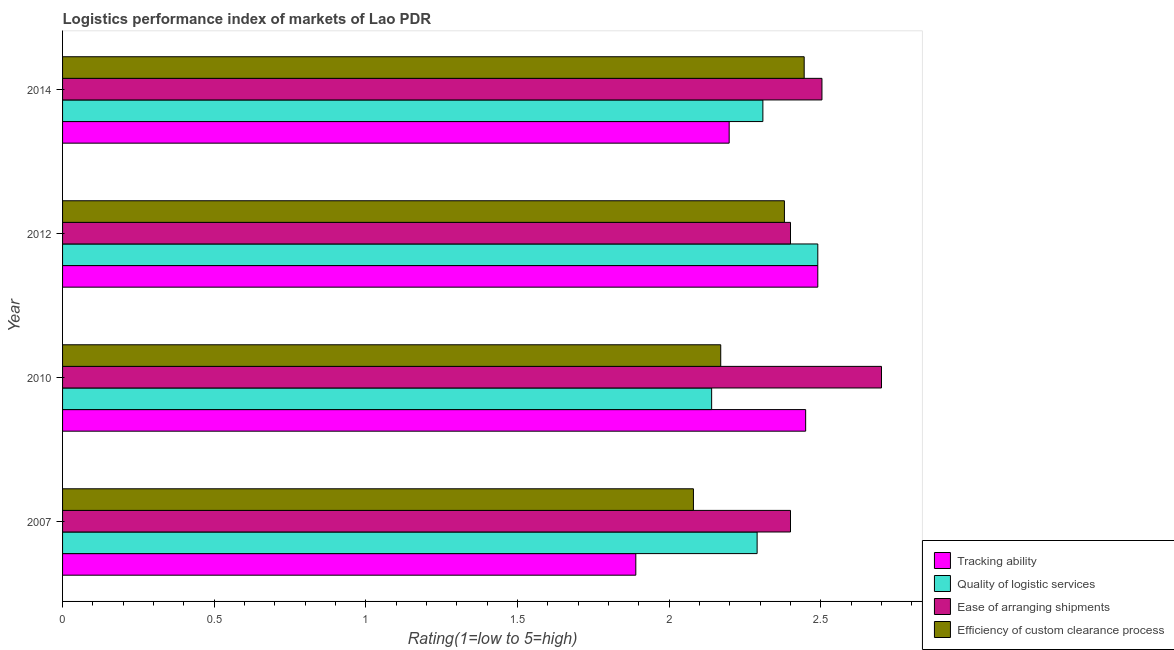Are the number of bars per tick equal to the number of legend labels?
Your answer should be compact. Yes. Are the number of bars on each tick of the Y-axis equal?
Your answer should be compact. Yes. How many bars are there on the 4th tick from the top?
Your response must be concise. 4. How many bars are there on the 1st tick from the bottom?
Keep it short and to the point. 4. What is the lpi rating of quality of logistic services in 2014?
Make the answer very short. 2.31. Across all years, what is the maximum lpi rating of tracking ability?
Your answer should be compact. 2.49. Across all years, what is the minimum lpi rating of ease of arranging shipments?
Offer a very short reply. 2.4. In which year was the lpi rating of tracking ability minimum?
Provide a short and direct response. 2007. What is the total lpi rating of efficiency of custom clearance process in the graph?
Offer a terse response. 9.08. What is the difference between the lpi rating of efficiency of custom clearance process in 2012 and that in 2014?
Your answer should be very brief. -0.07. What is the difference between the lpi rating of tracking ability in 2012 and the lpi rating of quality of logistic services in 2014?
Your answer should be compact. 0.18. What is the average lpi rating of tracking ability per year?
Make the answer very short. 2.26. In the year 2010, what is the difference between the lpi rating of quality of logistic services and lpi rating of tracking ability?
Make the answer very short. -0.31. In how many years, is the lpi rating of tracking ability greater than 1.3 ?
Offer a very short reply. 4. What is the ratio of the lpi rating of quality of logistic services in 2007 to that in 2014?
Offer a very short reply. 0.99. Is the lpi rating of ease of arranging shipments in 2007 less than that in 2014?
Give a very brief answer. Yes. What is the difference between the highest and the second highest lpi rating of tracking ability?
Make the answer very short. 0.04. Is it the case that in every year, the sum of the lpi rating of quality of logistic services and lpi rating of tracking ability is greater than the sum of lpi rating of ease of arranging shipments and lpi rating of efficiency of custom clearance process?
Make the answer very short. No. What does the 1st bar from the top in 2014 represents?
Ensure brevity in your answer.  Efficiency of custom clearance process. What does the 1st bar from the bottom in 2010 represents?
Offer a very short reply. Tracking ability. Is it the case that in every year, the sum of the lpi rating of tracking ability and lpi rating of quality of logistic services is greater than the lpi rating of ease of arranging shipments?
Provide a succinct answer. Yes. Are all the bars in the graph horizontal?
Keep it short and to the point. Yes. How many years are there in the graph?
Offer a terse response. 4. Does the graph contain any zero values?
Keep it short and to the point. No. Where does the legend appear in the graph?
Your answer should be very brief. Bottom right. How many legend labels are there?
Your answer should be compact. 4. What is the title of the graph?
Offer a terse response. Logistics performance index of markets of Lao PDR. Does "UNHCR" appear as one of the legend labels in the graph?
Give a very brief answer. No. What is the label or title of the X-axis?
Provide a succinct answer. Rating(1=low to 5=high). What is the Rating(1=low to 5=high) of Tracking ability in 2007?
Keep it short and to the point. 1.89. What is the Rating(1=low to 5=high) in Quality of logistic services in 2007?
Provide a succinct answer. 2.29. What is the Rating(1=low to 5=high) of Efficiency of custom clearance process in 2007?
Keep it short and to the point. 2.08. What is the Rating(1=low to 5=high) in Tracking ability in 2010?
Provide a succinct answer. 2.45. What is the Rating(1=low to 5=high) of Quality of logistic services in 2010?
Offer a very short reply. 2.14. What is the Rating(1=low to 5=high) in Ease of arranging shipments in 2010?
Your answer should be compact. 2.7. What is the Rating(1=low to 5=high) of Efficiency of custom clearance process in 2010?
Your response must be concise. 2.17. What is the Rating(1=low to 5=high) of Tracking ability in 2012?
Your response must be concise. 2.49. What is the Rating(1=low to 5=high) of Quality of logistic services in 2012?
Your response must be concise. 2.49. What is the Rating(1=low to 5=high) in Efficiency of custom clearance process in 2012?
Ensure brevity in your answer.  2.38. What is the Rating(1=low to 5=high) in Tracking ability in 2014?
Ensure brevity in your answer.  2.2. What is the Rating(1=low to 5=high) in Quality of logistic services in 2014?
Provide a succinct answer. 2.31. What is the Rating(1=low to 5=high) of Ease of arranging shipments in 2014?
Keep it short and to the point. 2.5. What is the Rating(1=low to 5=high) in Efficiency of custom clearance process in 2014?
Offer a very short reply. 2.45. Across all years, what is the maximum Rating(1=low to 5=high) of Tracking ability?
Offer a terse response. 2.49. Across all years, what is the maximum Rating(1=low to 5=high) of Quality of logistic services?
Offer a terse response. 2.49. Across all years, what is the maximum Rating(1=low to 5=high) in Efficiency of custom clearance process?
Keep it short and to the point. 2.45. Across all years, what is the minimum Rating(1=low to 5=high) of Tracking ability?
Provide a short and direct response. 1.89. Across all years, what is the minimum Rating(1=low to 5=high) in Quality of logistic services?
Provide a succinct answer. 2.14. Across all years, what is the minimum Rating(1=low to 5=high) of Ease of arranging shipments?
Ensure brevity in your answer.  2.4. Across all years, what is the minimum Rating(1=low to 5=high) of Efficiency of custom clearance process?
Ensure brevity in your answer.  2.08. What is the total Rating(1=low to 5=high) of Tracking ability in the graph?
Give a very brief answer. 9.03. What is the total Rating(1=low to 5=high) of Quality of logistic services in the graph?
Your response must be concise. 9.23. What is the total Rating(1=low to 5=high) in Ease of arranging shipments in the graph?
Offer a terse response. 10. What is the total Rating(1=low to 5=high) of Efficiency of custom clearance process in the graph?
Make the answer very short. 9.08. What is the difference between the Rating(1=low to 5=high) of Tracking ability in 2007 and that in 2010?
Provide a succinct answer. -0.56. What is the difference between the Rating(1=low to 5=high) of Ease of arranging shipments in 2007 and that in 2010?
Ensure brevity in your answer.  -0.3. What is the difference between the Rating(1=low to 5=high) of Efficiency of custom clearance process in 2007 and that in 2010?
Ensure brevity in your answer.  -0.09. What is the difference between the Rating(1=low to 5=high) in Quality of logistic services in 2007 and that in 2012?
Keep it short and to the point. -0.2. What is the difference between the Rating(1=low to 5=high) in Efficiency of custom clearance process in 2007 and that in 2012?
Offer a terse response. -0.3. What is the difference between the Rating(1=low to 5=high) in Tracking ability in 2007 and that in 2014?
Offer a terse response. -0.31. What is the difference between the Rating(1=low to 5=high) of Quality of logistic services in 2007 and that in 2014?
Your answer should be compact. -0.02. What is the difference between the Rating(1=low to 5=high) in Ease of arranging shipments in 2007 and that in 2014?
Provide a succinct answer. -0.1. What is the difference between the Rating(1=low to 5=high) in Efficiency of custom clearance process in 2007 and that in 2014?
Offer a very short reply. -0.37. What is the difference between the Rating(1=low to 5=high) in Tracking ability in 2010 and that in 2012?
Keep it short and to the point. -0.04. What is the difference between the Rating(1=low to 5=high) in Quality of logistic services in 2010 and that in 2012?
Provide a succinct answer. -0.35. What is the difference between the Rating(1=low to 5=high) of Efficiency of custom clearance process in 2010 and that in 2012?
Offer a very short reply. -0.21. What is the difference between the Rating(1=low to 5=high) in Tracking ability in 2010 and that in 2014?
Ensure brevity in your answer.  0.25. What is the difference between the Rating(1=low to 5=high) in Quality of logistic services in 2010 and that in 2014?
Provide a short and direct response. -0.17. What is the difference between the Rating(1=low to 5=high) of Ease of arranging shipments in 2010 and that in 2014?
Provide a succinct answer. 0.2. What is the difference between the Rating(1=low to 5=high) of Efficiency of custom clearance process in 2010 and that in 2014?
Keep it short and to the point. -0.28. What is the difference between the Rating(1=low to 5=high) in Tracking ability in 2012 and that in 2014?
Offer a terse response. 0.29. What is the difference between the Rating(1=low to 5=high) in Quality of logistic services in 2012 and that in 2014?
Your answer should be very brief. 0.18. What is the difference between the Rating(1=low to 5=high) of Ease of arranging shipments in 2012 and that in 2014?
Give a very brief answer. -0.1. What is the difference between the Rating(1=low to 5=high) in Efficiency of custom clearance process in 2012 and that in 2014?
Your response must be concise. -0.07. What is the difference between the Rating(1=low to 5=high) in Tracking ability in 2007 and the Rating(1=low to 5=high) in Ease of arranging shipments in 2010?
Your answer should be compact. -0.81. What is the difference between the Rating(1=low to 5=high) in Tracking ability in 2007 and the Rating(1=low to 5=high) in Efficiency of custom clearance process in 2010?
Ensure brevity in your answer.  -0.28. What is the difference between the Rating(1=low to 5=high) of Quality of logistic services in 2007 and the Rating(1=low to 5=high) of Ease of arranging shipments in 2010?
Give a very brief answer. -0.41. What is the difference between the Rating(1=low to 5=high) in Quality of logistic services in 2007 and the Rating(1=low to 5=high) in Efficiency of custom clearance process in 2010?
Your answer should be very brief. 0.12. What is the difference between the Rating(1=low to 5=high) of Ease of arranging shipments in 2007 and the Rating(1=low to 5=high) of Efficiency of custom clearance process in 2010?
Your answer should be compact. 0.23. What is the difference between the Rating(1=low to 5=high) in Tracking ability in 2007 and the Rating(1=low to 5=high) in Ease of arranging shipments in 2012?
Your answer should be compact. -0.51. What is the difference between the Rating(1=low to 5=high) in Tracking ability in 2007 and the Rating(1=low to 5=high) in Efficiency of custom clearance process in 2012?
Offer a very short reply. -0.49. What is the difference between the Rating(1=low to 5=high) of Quality of logistic services in 2007 and the Rating(1=low to 5=high) of Ease of arranging shipments in 2012?
Your answer should be compact. -0.11. What is the difference between the Rating(1=low to 5=high) in Quality of logistic services in 2007 and the Rating(1=low to 5=high) in Efficiency of custom clearance process in 2012?
Your answer should be compact. -0.09. What is the difference between the Rating(1=low to 5=high) in Tracking ability in 2007 and the Rating(1=low to 5=high) in Quality of logistic services in 2014?
Your answer should be compact. -0.42. What is the difference between the Rating(1=low to 5=high) of Tracking ability in 2007 and the Rating(1=low to 5=high) of Ease of arranging shipments in 2014?
Make the answer very short. -0.61. What is the difference between the Rating(1=low to 5=high) in Tracking ability in 2007 and the Rating(1=low to 5=high) in Efficiency of custom clearance process in 2014?
Give a very brief answer. -0.56. What is the difference between the Rating(1=low to 5=high) in Quality of logistic services in 2007 and the Rating(1=low to 5=high) in Ease of arranging shipments in 2014?
Your answer should be compact. -0.21. What is the difference between the Rating(1=low to 5=high) of Quality of logistic services in 2007 and the Rating(1=low to 5=high) of Efficiency of custom clearance process in 2014?
Keep it short and to the point. -0.16. What is the difference between the Rating(1=low to 5=high) of Ease of arranging shipments in 2007 and the Rating(1=low to 5=high) of Efficiency of custom clearance process in 2014?
Your response must be concise. -0.05. What is the difference between the Rating(1=low to 5=high) in Tracking ability in 2010 and the Rating(1=low to 5=high) in Quality of logistic services in 2012?
Offer a terse response. -0.04. What is the difference between the Rating(1=low to 5=high) in Tracking ability in 2010 and the Rating(1=low to 5=high) in Efficiency of custom clearance process in 2012?
Your answer should be compact. 0.07. What is the difference between the Rating(1=low to 5=high) of Quality of logistic services in 2010 and the Rating(1=low to 5=high) of Ease of arranging shipments in 2012?
Give a very brief answer. -0.26. What is the difference between the Rating(1=low to 5=high) of Quality of logistic services in 2010 and the Rating(1=low to 5=high) of Efficiency of custom clearance process in 2012?
Your answer should be compact. -0.24. What is the difference between the Rating(1=low to 5=high) in Ease of arranging shipments in 2010 and the Rating(1=low to 5=high) in Efficiency of custom clearance process in 2012?
Ensure brevity in your answer.  0.32. What is the difference between the Rating(1=low to 5=high) in Tracking ability in 2010 and the Rating(1=low to 5=high) in Quality of logistic services in 2014?
Offer a terse response. 0.14. What is the difference between the Rating(1=low to 5=high) in Tracking ability in 2010 and the Rating(1=low to 5=high) in Ease of arranging shipments in 2014?
Provide a short and direct response. -0.05. What is the difference between the Rating(1=low to 5=high) in Tracking ability in 2010 and the Rating(1=low to 5=high) in Efficiency of custom clearance process in 2014?
Make the answer very short. 0. What is the difference between the Rating(1=low to 5=high) in Quality of logistic services in 2010 and the Rating(1=low to 5=high) in Ease of arranging shipments in 2014?
Your response must be concise. -0.36. What is the difference between the Rating(1=low to 5=high) in Quality of logistic services in 2010 and the Rating(1=low to 5=high) in Efficiency of custom clearance process in 2014?
Offer a terse response. -0.31. What is the difference between the Rating(1=low to 5=high) in Ease of arranging shipments in 2010 and the Rating(1=low to 5=high) in Efficiency of custom clearance process in 2014?
Your response must be concise. 0.25. What is the difference between the Rating(1=low to 5=high) in Tracking ability in 2012 and the Rating(1=low to 5=high) in Quality of logistic services in 2014?
Provide a succinct answer. 0.18. What is the difference between the Rating(1=low to 5=high) in Tracking ability in 2012 and the Rating(1=low to 5=high) in Ease of arranging shipments in 2014?
Make the answer very short. -0.01. What is the difference between the Rating(1=low to 5=high) of Tracking ability in 2012 and the Rating(1=low to 5=high) of Efficiency of custom clearance process in 2014?
Your answer should be very brief. 0.04. What is the difference between the Rating(1=low to 5=high) in Quality of logistic services in 2012 and the Rating(1=low to 5=high) in Ease of arranging shipments in 2014?
Offer a terse response. -0.01. What is the difference between the Rating(1=low to 5=high) of Quality of logistic services in 2012 and the Rating(1=low to 5=high) of Efficiency of custom clearance process in 2014?
Keep it short and to the point. 0.04. What is the difference between the Rating(1=low to 5=high) in Ease of arranging shipments in 2012 and the Rating(1=low to 5=high) in Efficiency of custom clearance process in 2014?
Your response must be concise. -0.05. What is the average Rating(1=low to 5=high) in Tracking ability per year?
Your response must be concise. 2.26. What is the average Rating(1=low to 5=high) in Quality of logistic services per year?
Keep it short and to the point. 2.31. What is the average Rating(1=low to 5=high) of Ease of arranging shipments per year?
Provide a short and direct response. 2.5. What is the average Rating(1=low to 5=high) of Efficiency of custom clearance process per year?
Your answer should be compact. 2.27. In the year 2007, what is the difference between the Rating(1=low to 5=high) of Tracking ability and Rating(1=low to 5=high) of Quality of logistic services?
Offer a very short reply. -0.4. In the year 2007, what is the difference between the Rating(1=low to 5=high) in Tracking ability and Rating(1=low to 5=high) in Ease of arranging shipments?
Keep it short and to the point. -0.51. In the year 2007, what is the difference between the Rating(1=low to 5=high) in Tracking ability and Rating(1=low to 5=high) in Efficiency of custom clearance process?
Ensure brevity in your answer.  -0.19. In the year 2007, what is the difference between the Rating(1=low to 5=high) in Quality of logistic services and Rating(1=low to 5=high) in Ease of arranging shipments?
Provide a short and direct response. -0.11. In the year 2007, what is the difference between the Rating(1=low to 5=high) of Quality of logistic services and Rating(1=low to 5=high) of Efficiency of custom clearance process?
Your answer should be compact. 0.21. In the year 2007, what is the difference between the Rating(1=low to 5=high) in Ease of arranging shipments and Rating(1=low to 5=high) in Efficiency of custom clearance process?
Ensure brevity in your answer.  0.32. In the year 2010, what is the difference between the Rating(1=low to 5=high) in Tracking ability and Rating(1=low to 5=high) in Quality of logistic services?
Your answer should be compact. 0.31. In the year 2010, what is the difference between the Rating(1=low to 5=high) in Tracking ability and Rating(1=low to 5=high) in Efficiency of custom clearance process?
Your response must be concise. 0.28. In the year 2010, what is the difference between the Rating(1=low to 5=high) in Quality of logistic services and Rating(1=low to 5=high) in Ease of arranging shipments?
Offer a terse response. -0.56. In the year 2010, what is the difference between the Rating(1=low to 5=high) in Quality of logistic services and Rating(1=low to 5=high) in Efficiency of custom clearance process?
Provide a short and direct response. -0.03. In the year 2010, what is the difference between the Rating(1=low to 5=high) in Ease of arranging shipments and Rating(1=low to 5=high) in Efficiency of custom clearance process?
Offer a terse response. 0.53. In the year 2012, what is the difference between the Rating(1=low to 5=high) in Tracking ability and Rating(1=low to 5=high) in Ease of arranging shipments?
Ensure brevity in your answer.  0.09. In the year 2012, what is the difference between the Rating(1=low to 5=high) of Tracking ability and Rating(1=low to 5=high) of Efficiency of custom clearance process?
Make the answer very short. 0.11. In the year 2012, what is the difference between the Rating(1=low to 5=high) in Quality of logistic services and Rating(1=low to 5=high) in Ease of arranging shipments?
Provide a succinct answer. 0.09. In the year 2012, what is the difference between the Rating(1=low to 5=high) of Quality of logistic services and Rating(1=low to 5=high) of Efficiency of custom clearance process?
Give a very brief answer. 0.11. In the year 2014, what is the difference between the Rating(1=low to 5=high) in Tracking ability and Rating(1=low to 5=high) in Quality of logistic services?
Your response must be concise. -0.11. In the year 2014, what is the difference between the Rating(1=low to 5=high) in Tracking ability and Rating(1=low to 5=high) in Ease of arranging shipments?
Offer a terse response. -0.31. In the year 2014, what is the difference between the Rating(1=low to 5=high) of Tracking ability and Rating(1=low to 5=high) of Efficiency of custom clearance process?
Your response must be concise. -0.25. In the year 2014, what is the difference between the Rating(1=low to 5=high) of Quality of logistic services and Rating(1=low to 5=high) of Ease of arranging shipments?
Ensure brevity in your answer.  -0.19. In the year 2014, what is the difference between the Rating(1=low to 5=high) of Quality of logistic services and Rating(1=low to 5=high) of Efficiency of custom clearance process?
Give a very brief answer. -0.14. In the year 2014, what is the difference between the Rating(1=low to 5=high) of Ease of arranging shipments and Rating(1=low to 5=high) of Efficiency of custom clearance process?
Your response must be concise. 0.06. What is the ratio of the Rating(1=low to 5=high) in Tracking ability in 2007 to that in 2010?
Keep it short and to the point. 0.77. What is the ratio of the Rating(1=low to 5=high) in Quality of logistic services in 2007 to that in 2010?
Your answer should be compact. 1.07. What is the ratio of the Rating(1=low to 5=high) of Efficiency of custom clearance process in 2007 to that in 2010?
Your response must be concise. 0.96. What is the ratio of the Rating(1=low to 5=high) in Tracking ability in 2007 to that in 2012?
Provide a short and direct response. 0.76. What is the ratio of the Rating(1=low to 5=high) of Quality of logistic services in 2007 to that in 2012?
Your answer should be compact. 0.92. What is the ratio of the Rating(1=low to 5=high) of Ease of arranging shipments in 2007 to that in 2012?
Provide a short and direct response. 1. What is the ratio of the Rating(1=low to 5=high) in Efficiency of custom clearance process in 2007 to that in 2012?
Ensure brevity in your answer.  0.87. What is the ratio of the Rating(1=low to 5=high) of Tracking ability in 2007 to that in 2014?
Give a very brief answer. 0.86. What is the ratio of the Rating(1=low to 5=high) of Ease of arranging shipments in 2007 to that in 2014?
Provide a short and direct response. 0.96. What is the ratio of the Rating(1=low to 5=high) in Efficiency of custom clearance process in 2007 to that in 2014?
Your answer should be compact. 0.85. What is the ratio of the Rating(1=low to 5=high) of Tracking ability in 2010 to that in 2012?
Offer a terse response. 0.98. What is the ratio of the Rating(1=low to 5=high) in Quality of logistic services in 2010 to that in 2012?
Offer a terse response. 0.86. What is the ratio of the Rating(1=low to 5=high) in Efficiency of custom clearance process in 2010 to that in 2012?
Offer a very short reply. 0.91. What is the ratio of the Rating(1=low to 5=high) in Tracking ability in 2010 to that in 2014?
Give a very brief answer. 1.11. What is the ratio of the Rating(1=low to 5=high) in Quality of logistic services in 2010 to that in 2014?
Your response must be concise. 0.93. What is the ratio of the Rating(1=low to 5=high) of Ease of arranging shipments in 2010 to that in 2014?
Keep it short and to the point. 1.08. What is the ratio of the Rating(1=low to 5=high) of Efficiency of custom clearance process in 2010 to that in 2014?
Offer a very short reply. 0.89. What is the ratio of the Rating(1=low to 5=high) of Tracking ability in 2012 to that in 2014?
Offer a very short reply. 1.13. What is the ratio of the Rating(1=low to 5=high) of Quality of logistic services in 2012 to that in 2014?
Offer a terse response. 1.08. What is the ratio of the Rating(1=low to 5=high) in Ease of arranging shipments in 2012 to that in 2014?
Offer a terse response. 0.96. What is the ratio of the Rating(1=low to 5=high) in Efficiency of custom clearance process in 2012 to that in 2014?
Your response must be concise. 0.97. What is the difference between the highest and the second highest Rating(1=low to 5=high) of Tracking ability?
Your answer should be compact. 0.04. What is the difference between the highest and the second highest Rating(1=low to 5=high) in Quality of logistic services?
Provide a succinct answer. 0.18. What is the difference between the highest and the second highest Rating(1=low to 5=high) in Ease of arranging shipments?
Offer a very short reply. 0.2. What is the difference between the highest and the second highest Rating(1=low to 5=high) of Efficiency of custom clearance process?
Offer a terse response. 0.07. What is the difference between the highest and the lowest Rating(1=low to 5=high) of Ease of arranging shipments?
Your answer should be compact. 0.3. What is the difference between the highest and the lowest Rating(1=low to 5=high) in Efficiency of custom clearance process?
Offer a terse response. 0.37. 